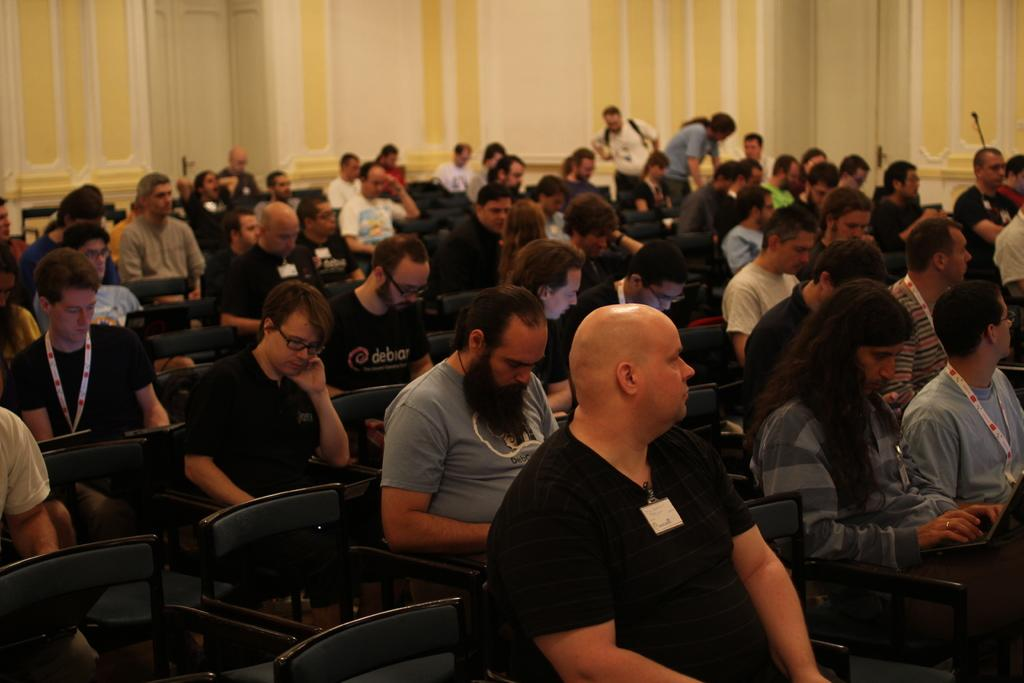How many people are in the image? There is a group of people in the image. What are some of the people doing in the image? Some people are sitting on chairs, while others are standing near a wall. What might suggest that the people are engaged in a shared activity? The people are listening to something, which indicates they are participating in a common activity. What type of sheet is being used to ride the bike in the image? There is no bike or sheet present in the image; the people are simply standing or sitting. 